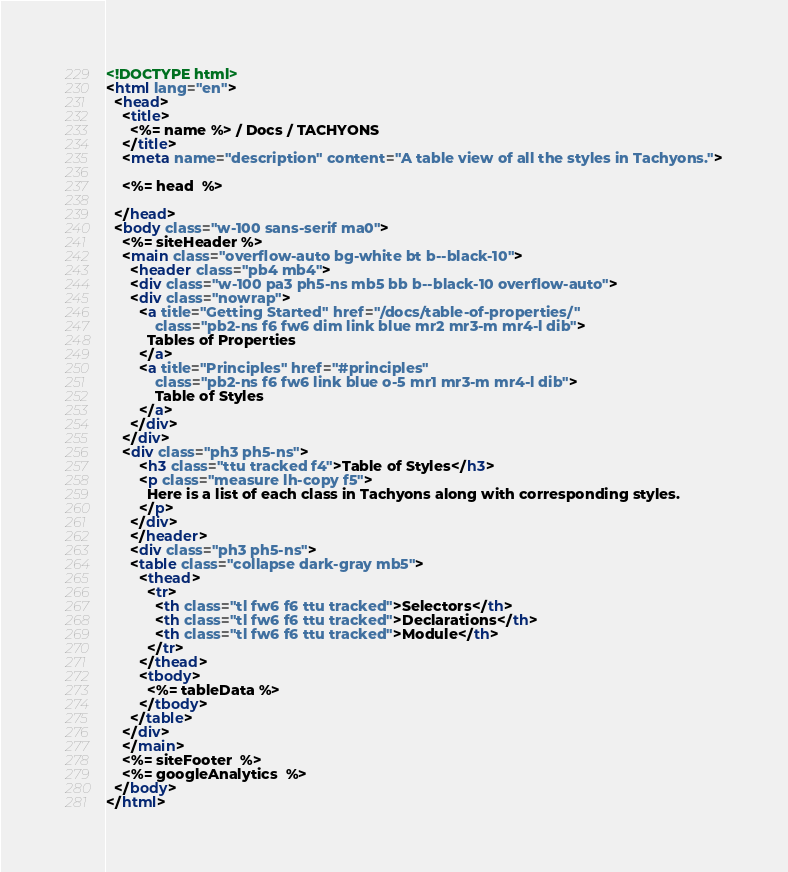Convert code to text. <code><loc_0><loc_0><loc_500><loc_500><_HTML_><!DOCTYPE html>
<html lang="en">
  <head>
    <title>
      <%= name %> / Docs / TACHYONS
    </title>
    <meta name="description" content="A table view of all the styles in Tachyons.">

    <%= head  %>

  </head>
  <body class="w-100 sans-serif ma0">
    <%= siteHeader %>
    <main class="overflow-auto bg-white bt b--black-10">
      <header class="pb4 mb4">
      <div class="w-100 pa3 ph5-ns mb5 bb b--black-10 overflow-auto">
      <div class="nowrap">
        <a title="Getting Started" href="/docs/table-of-properties/"
            class="pb2-ns f6 fw6 dim link blue mr2 mr3-m mr4-l dib">
          Tables of Properties
        </a>
        <a title="Principles" href="#principles"
            class="pb2-ns f6 fw6 link blue o-5 mr1 mr3-m mr4-l dib">
            Table of Styles
        </a>
      </div>
    </div>
    <div class="ph3 ph5-ns">
        <h3 class="ttu tracked f4">Table of Styles</h3>
        <p class="measure lh-copy f5">
          Here is a list of each class in Tachyons along with corresponding styles.
        </p>
      </div>
      </header>
      <div class="ph3 ph5-ns">
      <table class="collapse dark-gray mb5">
        <thead>
          <tr>
            <th class="tl fw6 f6 ttu tracked">Selectors</th>
            <th class="tl fw6 f6 ttu tracked">Declarations</th>
            <th class="tl fw6 f6 ttu tracked">Module</th>
          </tr>
        </thead>
        <tbody>
          <%= tableData %>
        </tbody>
      </table>
    </div>
    </main>
    <%= siteFooter  %>
    <%= googleAnalytics  %>
  </body>
</html>
</code> 